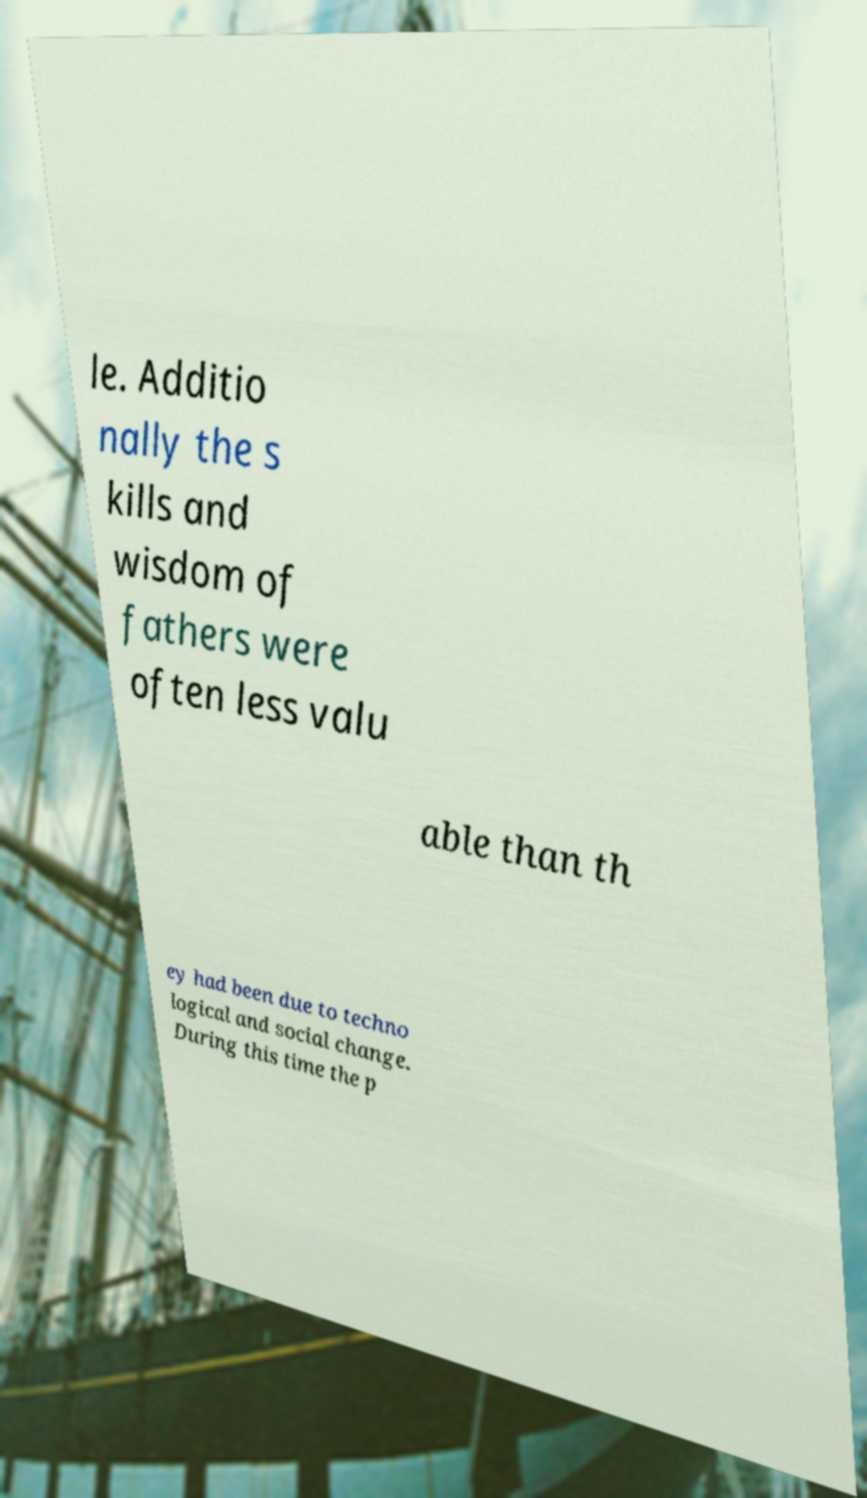Please identify and transcribe the text found in this image. le. Additio nally the s kills and wisdom of fathers were often less valu able than th ey had been due to techno logical and social change. During this time the p 